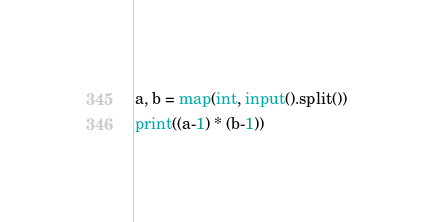Convert code to text. <code><loc_0><loc_0><loc_500><loc_500><_Python_>a, b = map(int, input().split())
print((a-1) * (b-1))</code> 